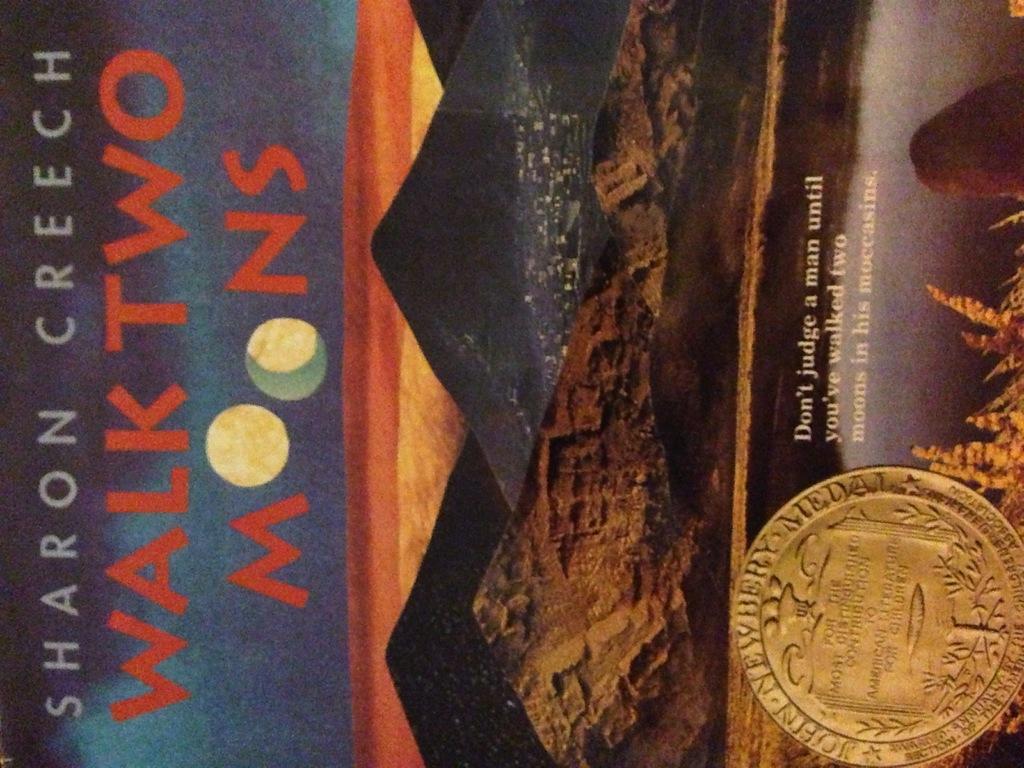What is the title of this book?
Offer a terse response. Walk two moons. Who wrote this book?
Your answer should be compact. Sharon creech. 